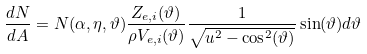Convert formula to latex. <formula><loc_0><loc_0><loc_500><loc_500>\frac { d N } { d A } = N ( \alpha , \eta , \vartheta ) \frac { Z _ { e , i } ( \vartheta ) } { \rho V _ { e , i } ( \vartheta ) } \frac { 1 } { \sqrt { u ^ { 2 } - \cos ^ { 2 } ( \vartheta ) } } \sin ( \vartheta ) d \vartheta</formula> 